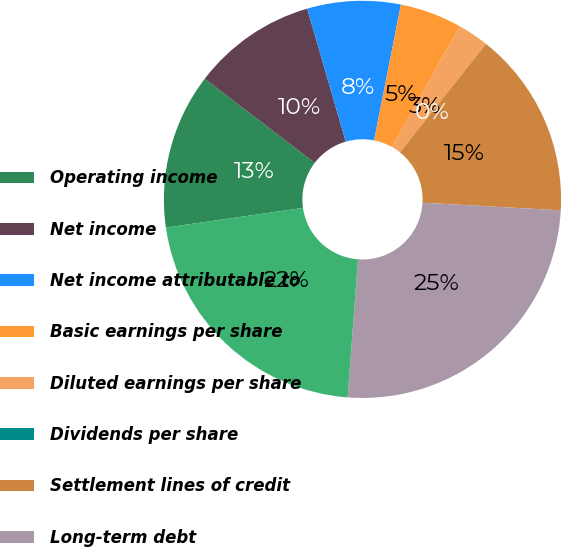Convert chart to OTSL. <chart><loc_0><loc_0><loc_500><loc_500><pie_chart><fcel>Operating income<fcel>Net income<fcel>Net income attributable to<fcel>Basic earnings per share<fcel>Diluted earnings per share<fcel>Dividends per share<fcel>Settlement lines of credit<fcel>Long-term debt<fcel>Total equity<nl><fcel>12.66%<fcel>10.12%<fcel>7.59%<fcel>5.06%<fcel>2.53%<fcel>0.0%<fcel>15.19%<fcel>25.31%<fcel>21.54%<nl></chart> 